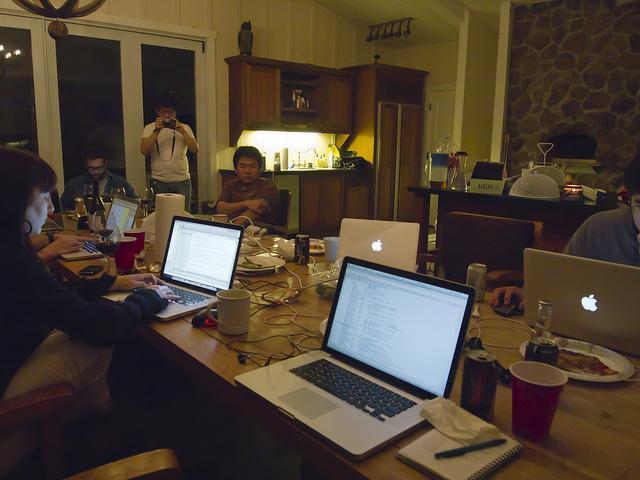How many devices does she appear to be using?
Give a very brief answer. 1. How many laptops can you see?
Give a very brief answer. 4. How many chairs can be seen?
Give a very brief answer. 3. How many people are visible?
Give a very brief answer. 5. 